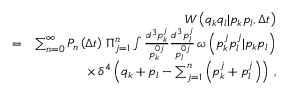<formula> <loc_0><loc_0><loc_500><loc_500>\begin{array} { r l r } & { W \left ( q _ { k } q _ { l } | p _ { k } p _ { l } , \Delta t \right ) } \\ & { = } & { \sum _ { n = 0 } ^ { \infty } P _ { n } \left ( \Delta t \right ) \, \Pi _ { j = 1 } ^ { n } \int \frac { d ^ { 3 } p _ { k } ^ { j } } { p _ { k } ^ { 0 j } } \frac { d ^ { 3 } p _ { l } ^ { j } } { p _ { l } ^ { 0 j } } \, \omega \left ( p _ { k } ^ { j } p _ { l } ^ { j } | p _ { k } p _ { l } \right ) } \\ & { \times \, \delta ^ { 4 } \left ( q _ { k } + p _ { l } - \sum _ { j = 1 } ^ { n } \left ( p _ { k } ^ { j } + p _ { l } ^ { j } \right ) \right ) \, , } \end{array}</formula> 